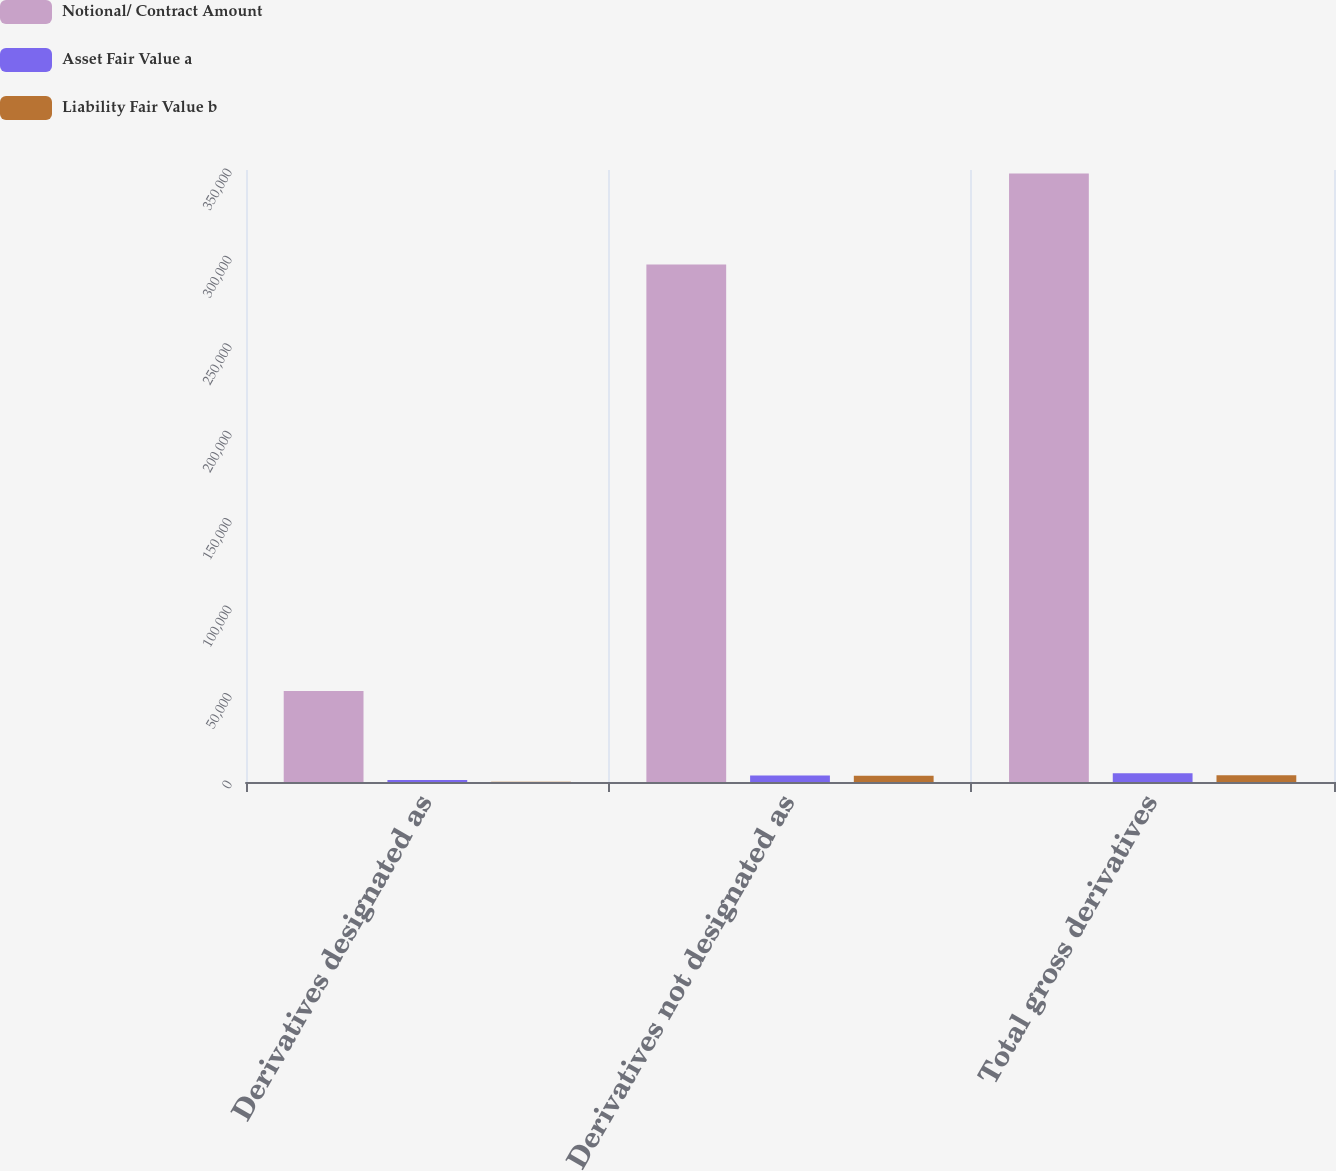Convert chart. <chart><loc_0><loc_0><loc_500><loc_500><stacked_bar_chart><ecel><fcel>Derivatives designated as<fcel>Derivatives not designated as<fcel>Total gross derivatives<nl><fcel>Notional/ Contract Amount<fcel>52074<fcel>295902<fcel>347976<nl><fcel>Asset Fair Value a<fcel>1159<fcel>3782<fcel>4941<nl><fcel>Liability Fair Value b<fcel>174<fcel>3628<fcel>3802<nl></chart> 